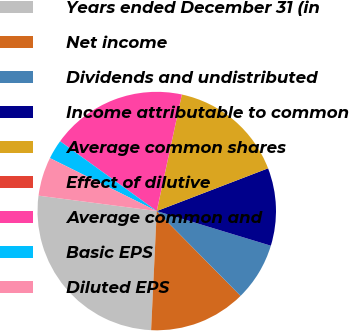<chart> <loc_0><loc_0><loc_500><loc_500><pie_chart><fcel>Years ended December 31 (in<fcel>Net income<fcel>Dividends and undistributed<fcel>Income attributable to common<fcel>Average common shares<fcel>Effect of dilutive<fcel>Average common and<fcel>Basic EPS<fcel>Diluted EPS<nl><fcel>26.31%<fcel>13.16%<fcel>7.9%<fcel>10.53%<fcel>15.79%<fcel>0.0%<fcel>18.42%<fcel>2.63%<fcel>5.26%<nl></chart> 